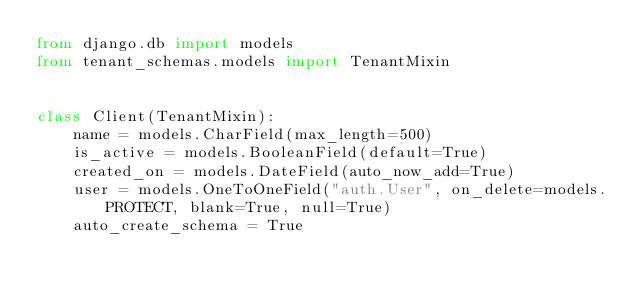Convert code to text. <code><loc_0><loc_0><loc_500><loc_500><_Python_>from django.db import models
from tenant_schemas.models import TenantMixin


class Client(TenantMixin):
    name = models.CharField(max_length=500)
    is_active = models.BooleanField(default=True)
    created_on = models.DateField(auto_now_add=True)
    user = models.OneToOneField("auth.User", on_delete=models.PROTECT, blank=True, null=True)
    auto_create_schema = True

</code> 